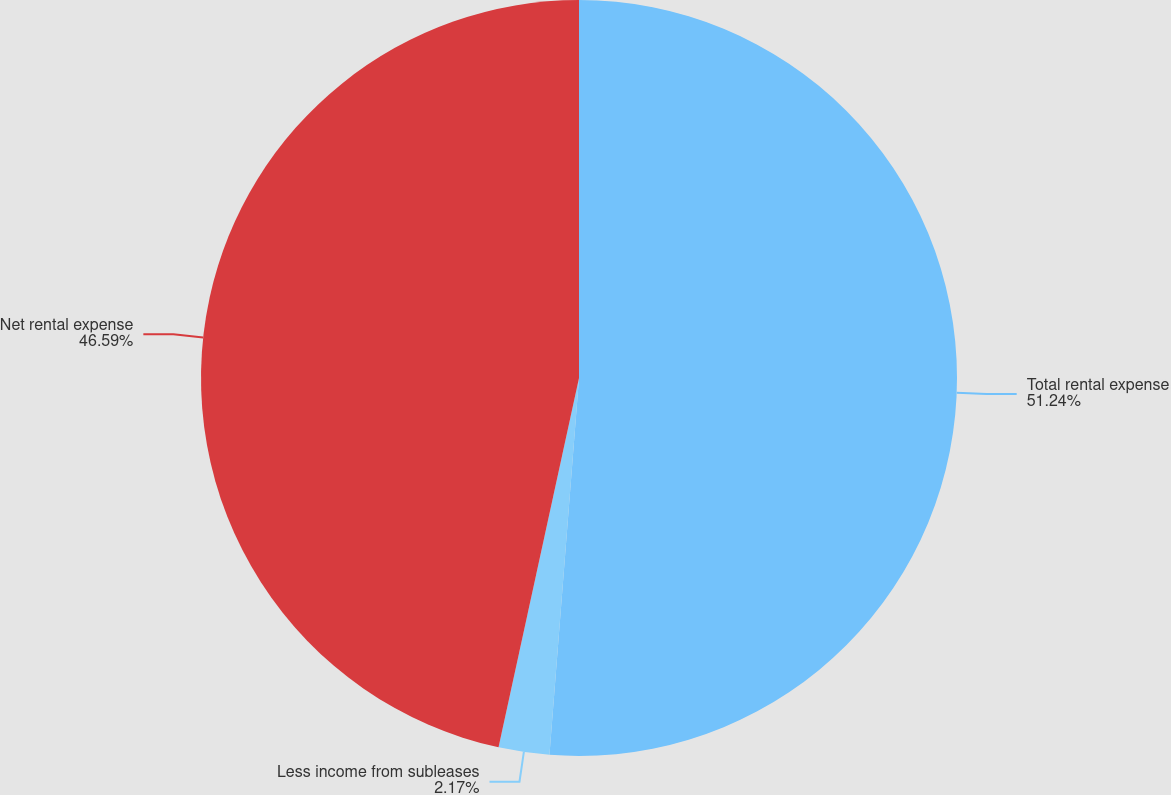Convert chart to OTSL. <chart><loc_0><loc_0><loc_500><loc_500><pie_chart><fcel>Total rental expense<fcel>Less income from subleases<fcel>Net rental expense<nl><fcel>51.25%<fcel>2.17%<fcel>46.59%<nl></chart> 